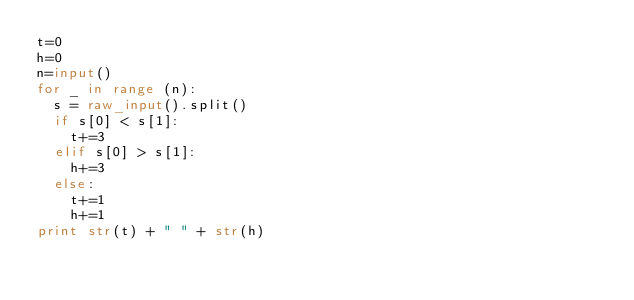Convert code to text. <code><loc_0><loc_0><loc_500><loc_500><_Python_>t=0
h=0
n=input()
for _ in range (n):
	s = raw_input().split()
	if s[0] < s[1]:
		t+=3
	elif s[0] > s[1]:
		h+=3
	else:
		t+=1
		h+=1
print str(t) + " " + str(h)
</code> 